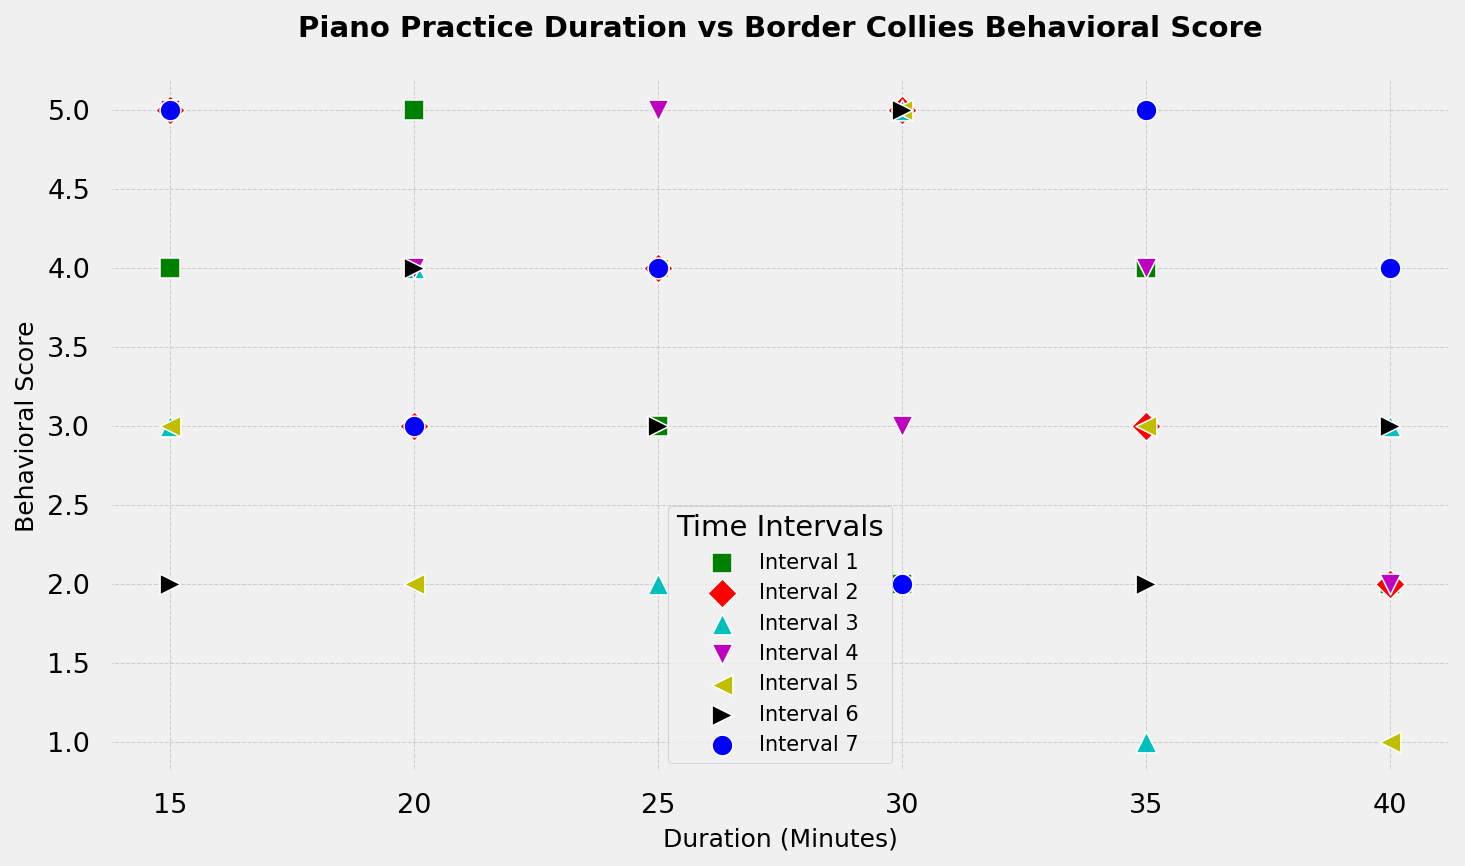What's the relationship between duration and behavioral score in Interval 1? By looking at Interval 1 (color-coded and labeled in the legend), it is noted that the behavioral scores vary with changes in duration. Generally, the scores do not show a consistent upward or downward trend with duration.
Answer: No clear trend Which interval shows the lowest behavioral score for a 30-minute duration? Find the data points corresponding to a 30-minute duration across different intervals, and then compare the behavioral scores for each interval. Interval 7 shows the lowest score, which is 2.
Answer: Interval 7 Which interval exhibits the most variation in behavioral scores? By visually inspecting the spread of data points for each interval, you can see which interval has the most varied (largest range) behavioral scores. Interval 4 displays the most variation, with scores ranging from 2 to 5.
Answer: Interval 4 What's the range of behavioral scores in Interval 3? Locate Interval 3 in the plot and determine the minimum and maximum behavioral scores within this interval. The range is calculated as the maximum score (5) minus the minimum score (1).
Answer: 4 How does the relationship between duration and behavioral score compare between Interval 2 and Interval 5? Observe the data points for Intervals 2 and 5 (color-coded and labeled). Interval 2 generally shows a slight decrease in behavioral scores with increased duration, while Interval 5 shows more fluctuation with a slight downward trend.
Answer: Interval 2: slight decrease; Interval 5: fluctuates with slight downward trend At a duration of 20 minutes, which interval has the highest behavioral score, and what is it? Locate the 20-minute duration data points across the intervals and identify the one with the highest behavioral score. Interval 6 has the highest score at 4.
Answer: Interval 6 with score 4 What is the average behavioral score for a 15-minute duration across all intervals? Identify the behavioral scores corresponding to a 15-minute duration for all intervals (5, 5, 3, 5, 3, 2, 5), sum them (28), and then divide by the number of intervals (7).
Answer: 4 How does Interval 7's behavioral score change with increasing duration from 15 to 40 minutes? Observe the data points for Interval 7 (color-coded and labeled), noting the behavioral score for each duration. The scores are 5, 3, 4, 2, 5, and 4, which shows a varied pattern without a clear trend.
Answer: Varied pattern 